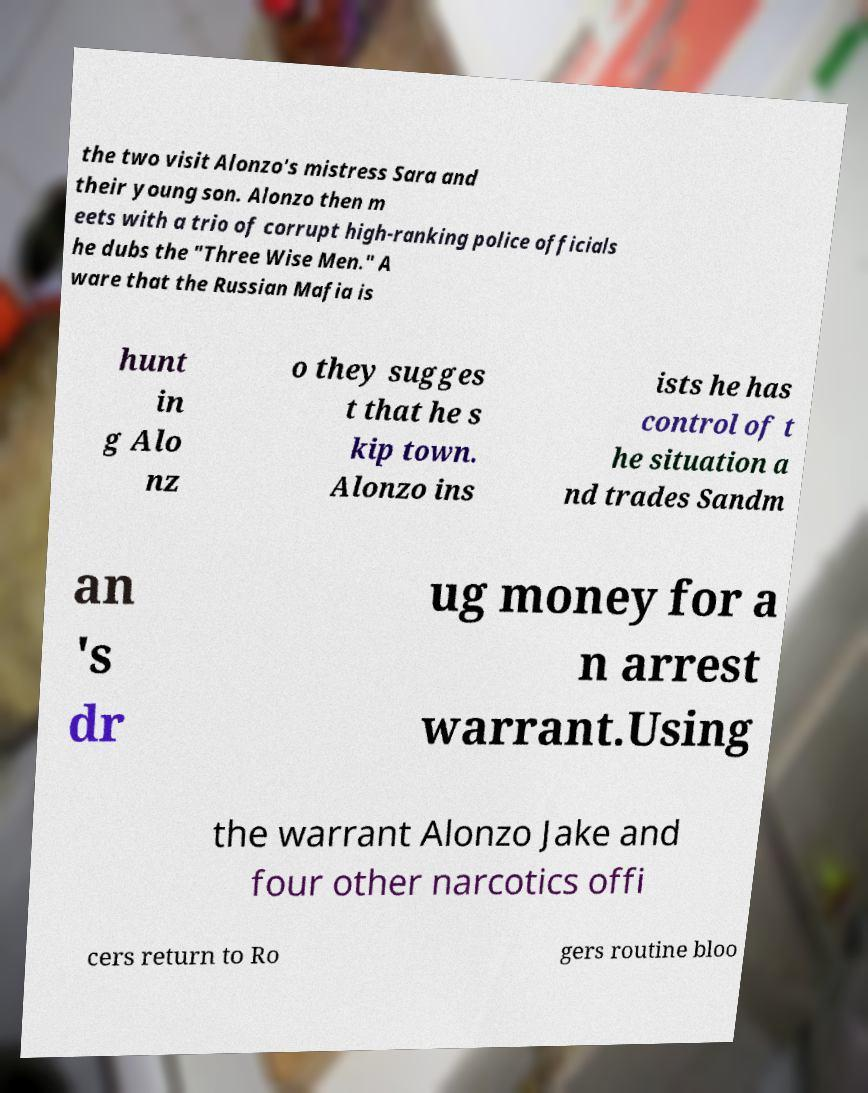Please identify and transcribe the text found in this image. the two visit Alonzo's mistress Sara and their young son. Alonzo then m eets with a trio of corrupt high-ranking police officials he dubs the "Three Wise Men." A ware that the Russian Mafia is hunt in g Alo nz o they sugges t that he s kip town. Alonzo ins ists he has control of t he situation a nd trades Sandm an 's dr ug money for a n arrest warrant.Using the warrant Alonzo Jake and four other narcotics offi cers return to Ro gers routine bloo 